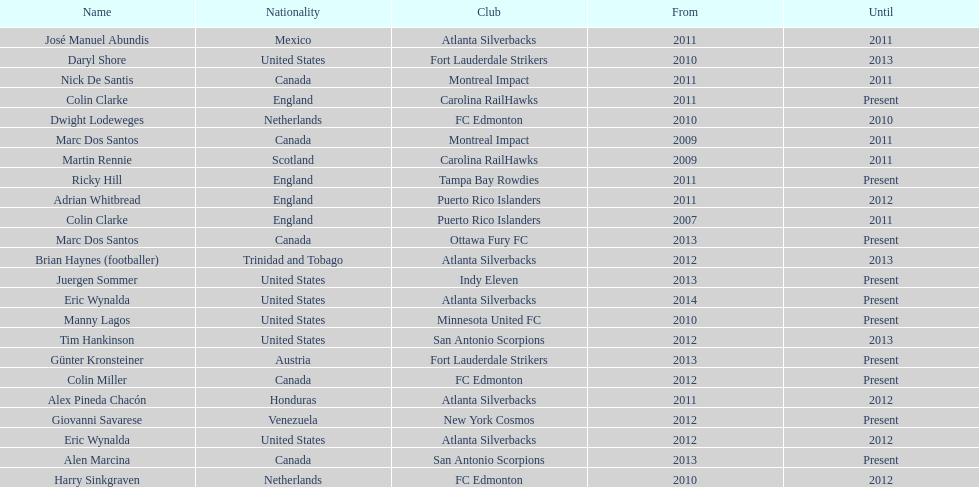Marc dos santos started as coach the same year as what other coach? Martin Rennie. 